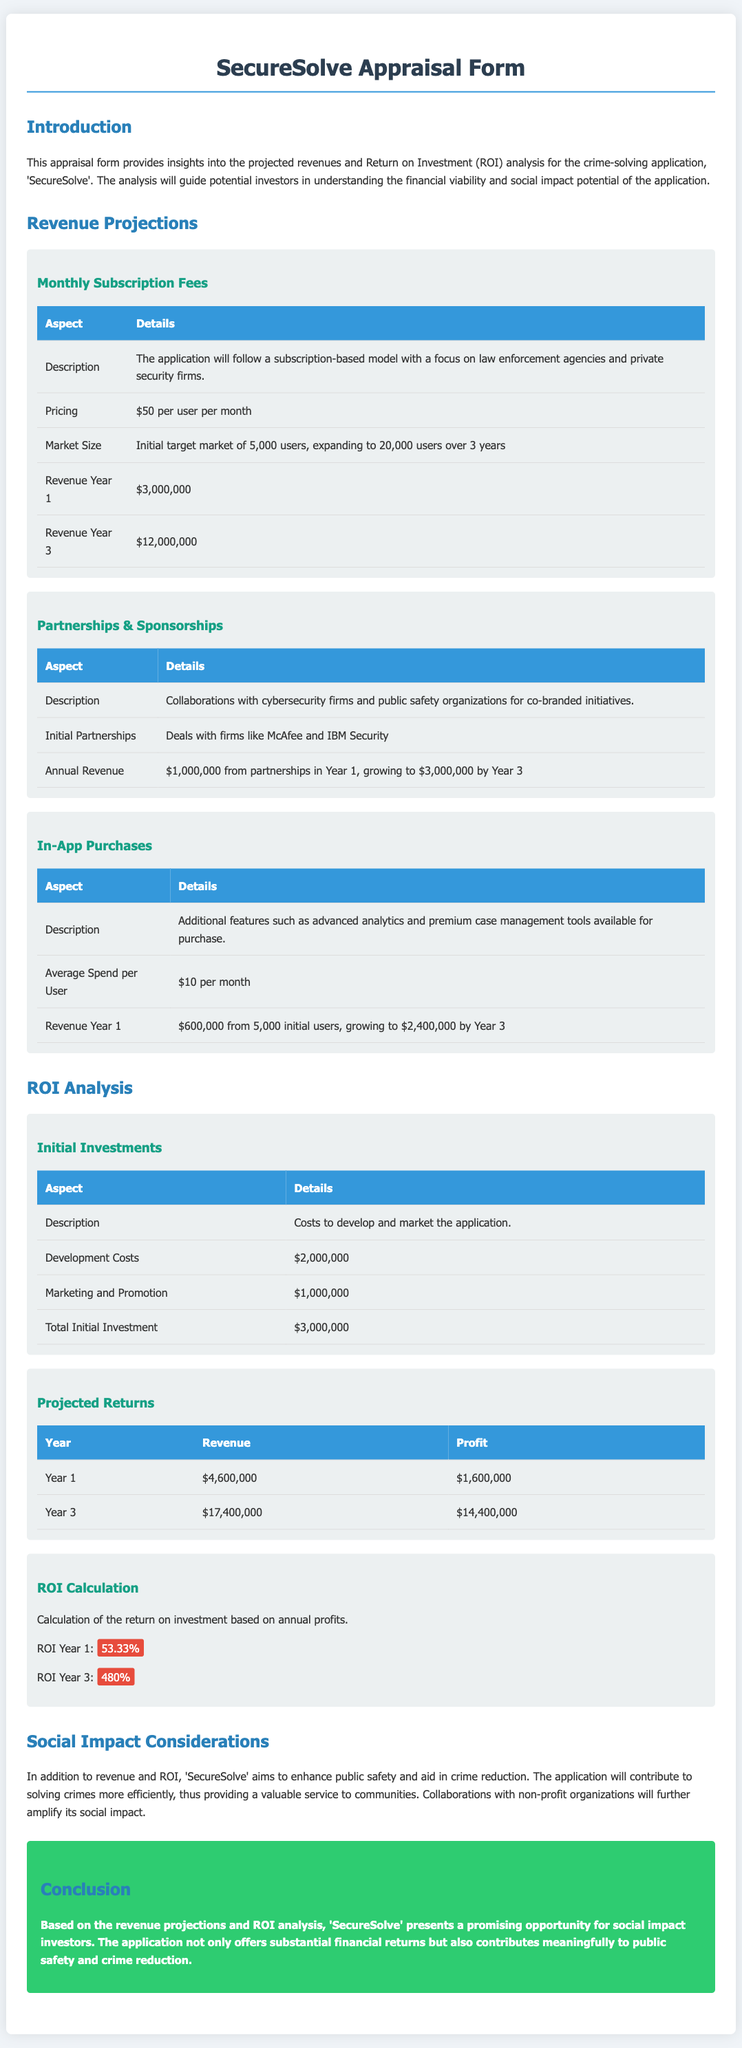What is the subscription fee per user per month? The pricing for the subscription model is explicitly stated in the document.
Answer: $50 What is the initial target market size? The document mentions the initial target market size for the application.
Answer: 5,000 users What are the total initial investments? The total amount invested to develop and market the application is summarized in the document.
Answer: $3,000,000 What is the projected revenue for Year 1? The document lists the revenue projections for the first year.
Answer: $4,600,000 What is the ROI for Year 3? The return on investment for the third year is calculated in the document.
Answer: 480% What companies are mentioned as initial partners? The document provides specifics about initial partnerships with certain firms.
Answer: McAfee and IBM Security What is the average spend per user for in-app purchases? This information regarding additional user spending is provided in the document.
Answer: $10 per month What is the expected revenue from partnerships in Year 3? The document specifies revenue growth from partnerships over time.
Answer: $3,000,000 What is the revenue for Year 3 from subscriptions? The document gives projections for subscription revenue by year.
Answer: $12,000,000 